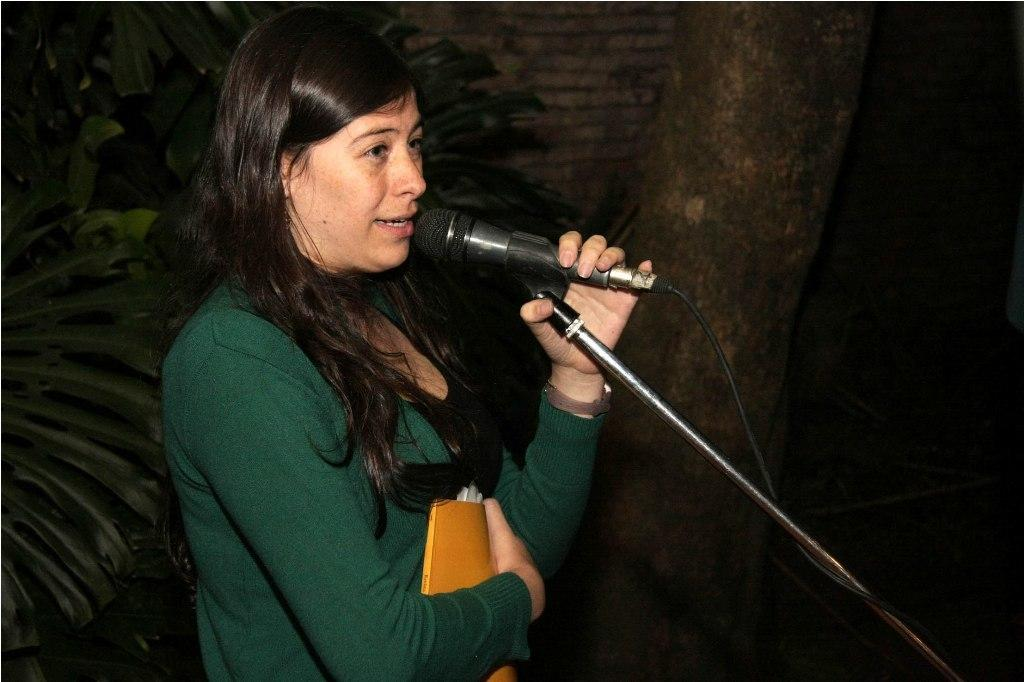Who is the main subject in the image? There is a woman in the image. What is the woman holding in her hands? The woman is holding a book and a mic. What can be seen in the background of the image? There is a tree and plants in the background of the image. What time does the clock show in the image? There is no clock present in the image. Can you describe the yak in the image? There is no yak present in the image. 